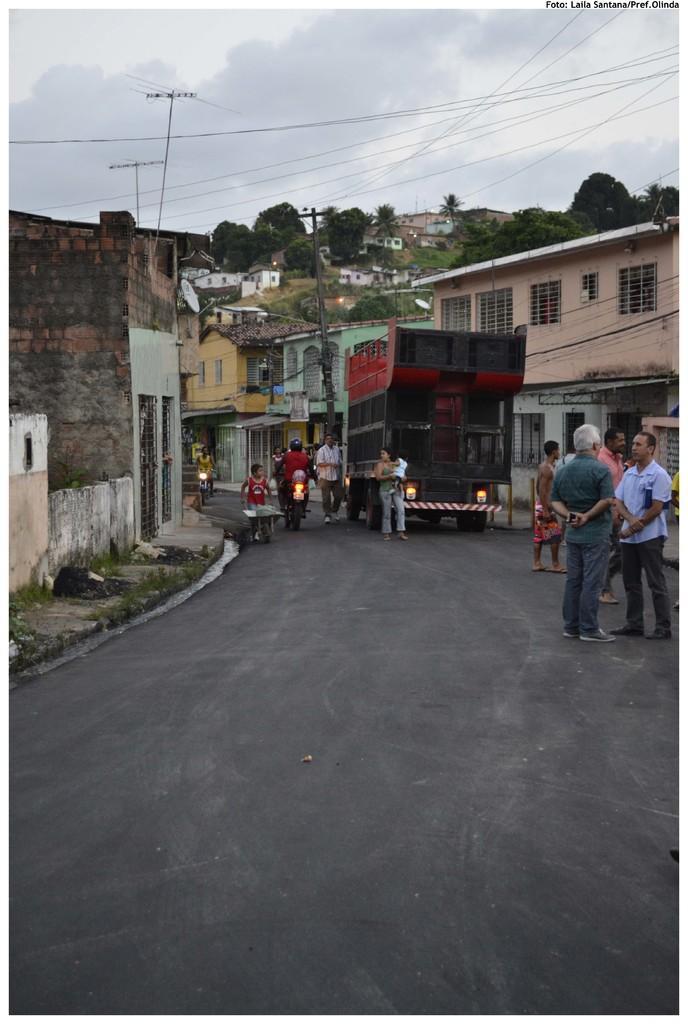In one or two sentences, can you explain what this image depicts? In this image we can see vehicles on the road and there are people. In the background there are buildings, poles, trees, wires and sky. 